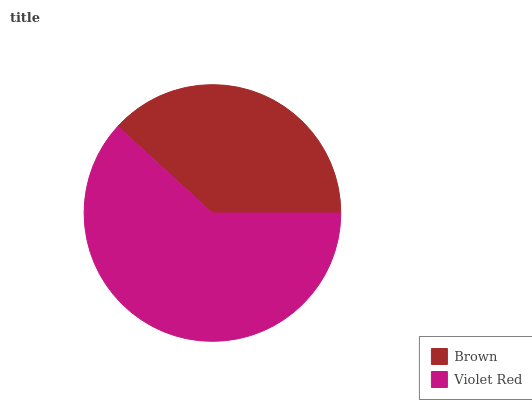Is Brown the minimum?
Answer yes or no. Yes. Is Violet Red the maximum?
Answer yes or no. Yes. Is Violet Red the minimum?
Answer yes or no. No. Is Violet Red greater than Brown?
Answer yes or no. Yes. Is Brown less than Violet Red?
Answer yes or no. Yes. Is Brown greater than Violet Red?
Answer yes or no. No. Is Violet Red less than Brown?
Answer yes or no. No. Is Violet Red the high median?
Answer yes or no. Yes. Is Brown the low median?
Answer yes or no. Yes. Is Brown the high median?
Answer yes or no. No. Is Violet Red the low median?
Answer yes or no. No. 